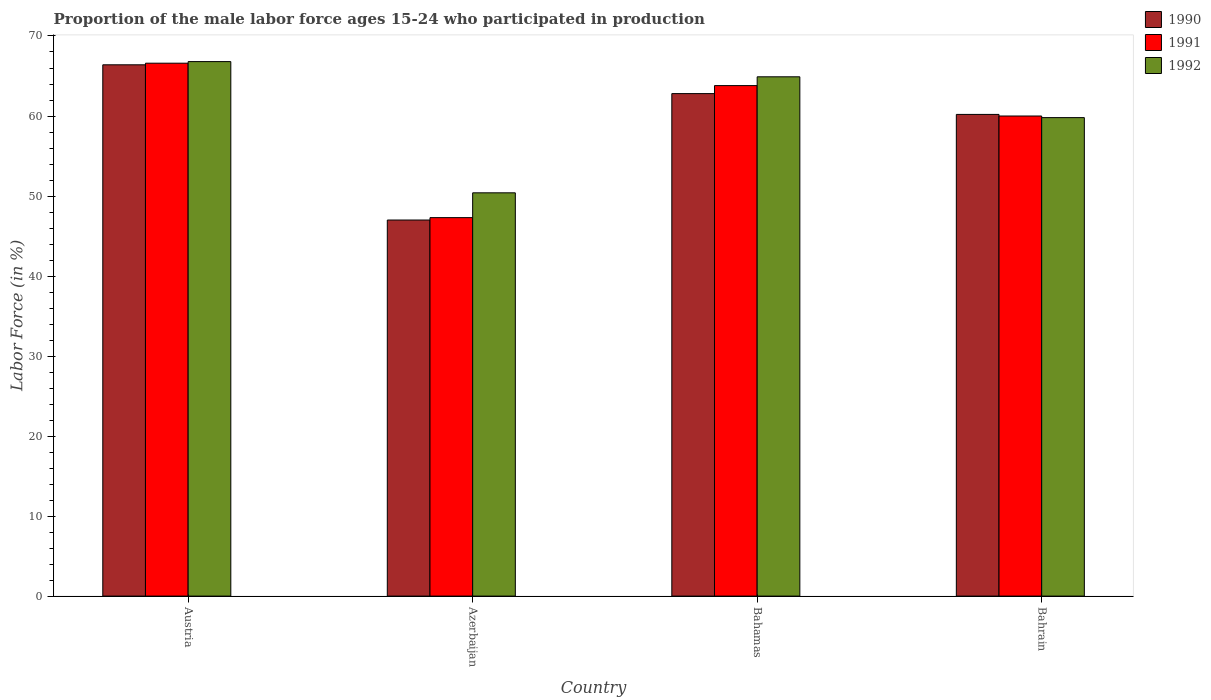How many different coloured bars are there?
Your answer should be compact. 3. How many groups of bars are there?
Ensure brevity in your answer.  4. Are the number of bars per tick equal to the number of legend labels?
Provide a succinct answer. Yes. What is the proportion of the male labor force who participated in production in 1992 in Azerbaijan?
Keep it short and to the point. 50.4. Across all countries, what is the maximum proportion of the male labor force who participated in production in 1992?
Offer a terse response. 66.8. In which country was the proportion of the male labor force who participated in production in 1991 minimum?
Give a very brief answer. Azerbaijan. What is the total proportion of the male labor force who participated in production in 1992 in the graph?
Make the answer very short. 241.9. What is the difference between the proportion of the male labor force who participated in production in 1990 in Austria and that in Bahrain?
Provide a short and direct response. 6.2. What is the difference between the proportion of the male labor force who participated in production in 1992 in Austria and the proportion of the male labor force who participated in production in 1991 in Azerbaijan?
Your answer should be compact. 19.5. What is the average proportion of the male labor force who participated in production in 1991 per country?
Offer a terse response. 59.42. What is the difference between the proportion of the male labor force who participated in production of/in 1991 and proportion of the male labor force who participated in production of/in 1992 in Bahrain?
Give a very brief answer. 0.2. In how many countries, is the proportion of the male labor force who participated in production in 1991 greater than 50 %?
Provide a succinct answer. 3. What is the ratio of the proportion of the male labor force who participated in production in 1991 in Azerbaijan to that in Bahrain?
Keep it short and to the point. 0.79. What is the difference between the highest and the second highest proportion of the male labor force who participated in production in 1990?
Your response must be concise. 6.2. What is the difference between the highest and the lowest proportion of the male labor force who participated in production in 1990?
Your response must be concise. 19.4. Is the sum of the proportion of the male labor force who participated in production in 1990 in Bahamas and Bahrain greater than the maximum proportion of the male labor force who participated in production in 1992 across all countries?
Provide a succinct answer. Yes. Are all the bars in the graph horizontal?
Give a very brief answer. No. Are the values on the major ticks of Y-axis written in scientific E-notation?
Your response must be concise. No. How many legend labels are there?
Your answer should be very brief. 3. What is the title of the graph?
Your answer should be compact. Proportion of the male labor force ages 15-24 who participated in production. What is the Labor Force (in %) in 1990 in Austria?
Your answer should be very brief. 66.4. What is the Labor Force (in %) in 1991 in Austria?
Your answer should be compact. 66.6. What is the Labor Force (in %) in 1992 in Austria?
Offer a very short reply. 66.8. What is the Labor Force (in %) of 1990 in Azerbaijan?
Give a very brief answer. 47. What is the Labor Force (in %) in 1991 in Azerbaijan?
Offer a terse response. 47.3. What is the Labor Force (in %) in 1992 in Azerbaijan?
Keep it short and to the point. 50.4. What is the Labor Force (in %) of 1990 in Bahamas?
Give a very brief answer. 62.8. What is the Labor Force (in %) in 1991 in Bahamas?
Your answer should be very brief. 63.8. What is the Labor Force (in %) in 1992 in Bahamas?
Your answer should be compact. 64.9. What is the Labor Force (in %) of 1990 in Bahrain?
Your response must be concise. 60.2. What is the Labor Force (in %) of 1992 in Bahrain?
Offer a terse response. 59.8. Across all countries, what is the maximum Labor Force (in %) of 1990?
Provide a succinct answer. 66.4. Across all countries, what is the maximum Labor Force (in %) of 1991?
Give a very brief answer. 66.6. Across all countries, what is the maximum Labor Force (in %) of 1992?
Provide a succinct answer. 66.8. Across all countries, what is the minimum Labor Force (in %) in 1991?
Offer a very short reply. 47.3. Across all countries, what is the minimum Labor Force (in %) of 1992?
Make the answer very short. 50.4. What is the total Labor Force (in %) of 1990 in the graph?
Make the answer very short. 236.4. What is the total Labor Force (in %) of 1991 in the graph?
Your answer should be compact. 237.7. What is the total Labor Force (in %) in 1992 in the graph?
Provide a short and direct response. 241.9. What is the difference between the Labor Force (in %) of 1991 in Austria and that in Azerbaijan?
Offer a very short reply. 19.3. What is the difference between the Labor Force (in %) of 1992 in Austria and that in Azerbaijan?
Your answer should be very brief. 16.4. What is the difference between the Labor Force (in %) in 1990 in Austria and that in Bahamas?
Your answer should be very brief. 3.6. What is the difference between the Labor Force (in %) in 1991 in Austria and that in Bahamas?
Provide a short and direct response. 2.8. What is the difference between the Labor Force (in %) of 1992 in Austria and that in Bahamas?
Your answer should be compact. 1.9. What is the difference between the Labor Force (in %) of 1992 in Austria and that in Bahrain?
Offer a very short reply. 7. What is the difference between the Labor Force (in %) in 1990 in Azerbaijan and that in Bahamas?
Offer a terse response. -15.8. What is the difference between the Labor Force (in %) in 1991 in Azerbaijan and that in Bahamas?
Ensure brevity in your answer.  -16.5. What is the difference between the Labor Force (in %) in 1991 in Azerbaijan and that in Bahrain?
Your answer should be compact. -12.7. What is the difference between the Labor Force (in %) in 1992 in Azerbaijan and that in Bahrain?
Offer a terse response. -9.4. What is the difference between the Labor Force (in %) of 1990 in Bahamas and that in Bahrain?
Your answer should be compact. 2.6. What is the difference between the Labor Force (in %) in 1992 in Bahamas and that in Bahrain?
Offer a very short reply. 5.1. What is the difference between the Labor Force (in %) in 1990 in Austria and the Labor Force (in %) in 1991 in Azerbaijan?
Ensure brevity in your answer.  19.1. What is the difference between the Labor Force (in %) of 1990 in Austria and the Labor Force (in %) of 1992 in Azerbaijan?
Provide a short and direct response. 16. What is the difference between the Labor Force (in %) of 1991 in Austria and the Labor Force (in %) of 1992 in Azerbaijan?
Make the answer very short. 16.2. What is the difference between the Labor Force (in %) in 1990 in Austria and the Labor Force (in %) in 1992 in Bahamas?
Make the answer very short. 1.5. What is the difference between the Labor Force (in %) in 1990 in Austria and the Labor Force (in %) in 1991 in Bahrain?
Give a very brief answer. 6.4. What is the difference between the Labor Force (in %) of 1990 in Austria and the Labor Force (in %) of 1992 in Bahrain?
Your answer should be compact. 6.6. What is the difference between the Labor Force (in %) of 1991 in Austria and the Labor Force (in %) of 1992 in Bahrain?
Make the answer very short. 6.8. What is the difference between the Labor Force (in %) in 1990 in Azerbaijan and the Labor Force (in %) in 1991 in Bahamas?
Your response must be concise. -16.8. What is the difference between the Labor Force (in %) in 1990 in Azerbaijan and the Labor Force (in %) in 1992 in Bahamas?
Your answer should be very brief. -17.9. What is the difference between the Labor Force (in %) of 1991 in Azerbaijan and the Labor Force (in %) of 1992 in Bahamas?
Provide a succinct answer. -17.6. What is the difference between the Labor Force (in %) in 1990 in Azerbaijan and the Labor Force (in %) in 1991 in Bahrain?
Give a very brief answer. -13. What is the difference between the Labor Force (in %) of 1990 in Azerbaijan and the Labor Force (in %) of 1992 in Bahrain?
Ensure brevity in your answer.  -12.8. What is the difference between the Labor Force (in %) of 1991 in Azerbaijan and the Labor Force (in %) of 1992 in Bahrain?
Your answer should be very brief. -12.5. What is the difference between the Labor Force (in %) in 1990 in Bahamas and the Labor Force (in %) in 1992 in Bahrain?
Give a very brief answer. 3. What is the difference between the Labor Force (in %) in 1991 in Bahamas and the Labor Force (in %) in 1992 in Bahrain?
Provide a succinct answer. 4. What is the average Labor Force (in %) of 1990 per country?
Your answer should be compact. 59.1. What is the average Labor Force (in %) in 1991 per country?
Ensure brevity in your answer.  59.42. What is the average Labor Force (in %) of 1992 per country?
Your answer should be very brief. 60.48. What is the difference between the Labor Force (in %) of 1990 and Labor Force (in %) of 1991 in Austria?
Provide a succinct answer. -0.2. What is the difference between the Labor Force (in %) in 1991 and Labor Force (in %) in 1992 in Austria?
Ensure brevity in your answer.  -0.2. What is the difference between the Labor Force (in %) in 1990 and Labor Force (in %) in 1991 in Azerbaijan?
Your answer should be very brief. -0.3. What is the difference between the Labor Force (in %) of 1990 and Labor Force (in %) of 1992 in Azerbaijan?
Offer a very short reply. -3.4. What is the difference between the Labor Force (in %) of 1991 and Labor Force (in %) of 1992 in Azerbaijan?
Offer a terse response. -3.1. What is the difference between the Labor Force (in %) in 1990 and Labor Force (in %) in 1991 in Bahamas?
Offer a terse response. -1. What is the difference between the Labor Force (in %) in 1990 and Labor Force (in %) in 1992 in Bahamas?
Provide a succinct answer. -2.1. What is the ratio of the Labor Force (in %) in 1990 in Austria to that in Azerbaijan?
Give a very brief answer. 1.41. What is the ratio of the Labor Force (in %) in 1991 in Austria to that in Azerbaijan?
Offer a terse response. 1.41. What is the ratio of the Labor Force (in %) of 1992 in Austria to that in Azerbaijan?
Give a very brief answer. 1.33. What is the ratio of the Labor Force (in %) in 1990 in Austria to that in Bahamas?
Offer a terse response. 1.06. What is the ratio of the Labor Force (in %) in 1991 in Austria to that in Bahamas?
Make the answer very short. 1.04. What is the ratio of the Labor Force (in %) in 1992 in Austria to that in Bahamas?
Provide a succinct answer. 1.03. What is the ratio of the Labor Force (in %) in 1990 in Austria to that in Bahrain?
Ensure brevity in your answer.  1.1. What is the ratio of the Labor Force (in %) of 1991 in Austria to that in Bahrain?
Provide a succinct answer. 1.11. What is the ratio of the Labor Force (in %) in 1992 in Austria to that in Bahrain?
Your answer should be very brief. 1.12. What is the ratio of the Labor Force (in %) of 1990 in Azerbaijan to that in Bahamas?
Your response must be concise. 0.75. What is the ratio of the Labor Force (in %) of 1991 in Azerbaijan to that in Bahamas?
Provide a succinct answer. 0.74. What is the ratio of the Labor Force (in %) in 1992 in Azerbaijan to that in Bahamas?
Your answer should be compact. 0.78. What is the ratio of the Labor Force (in %) of 1990 in Azerbaijan to that in Bahrain?
Provide a short and direct response. 0.78. What is the ratio of the Labor Force (in %) of 1991 in Azerbaijan to that in Bahrain?
Provide a succinct answer. 0.79. What is the ratio of the Labor Force (in %) in 1992 in Azerbaijan to that in Bahrain?
Keep it short and to the point. 0.84. What is the ratio of the Labor Force (in %) in 1990 in Bahamas to that in Bahrain?
Offer a terse response. 1.04. What is the ratio of the Labor Force (in %) in 1991 in Bahamas to that in Bahrain?
Give a very brief answer. 1.06. What is the ratio of the Labor Force (in %) in 1992 in Bahamas to that in Bahrain?
Give a very brief answer. 1.09. What is the difference between the highest and the lowest Labor Force (in %) of 1991?
Offer a very short reply. 19.3. 